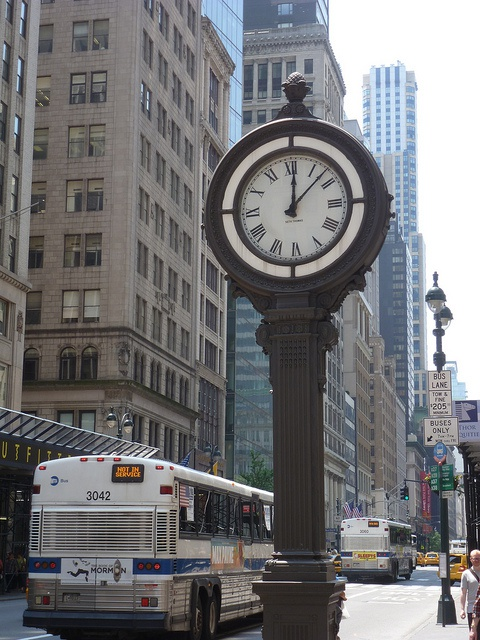Describe the objects in this image and their specific colors. I can see bus in gray, darkgray, black, and navy tones, clock in gray, darkgray, and black tones, bus in gray, darkgray, black, and lightgray tones, people in gray, lightgray, and darkgray tones, and car in gray, olive, and black tones in this image. 